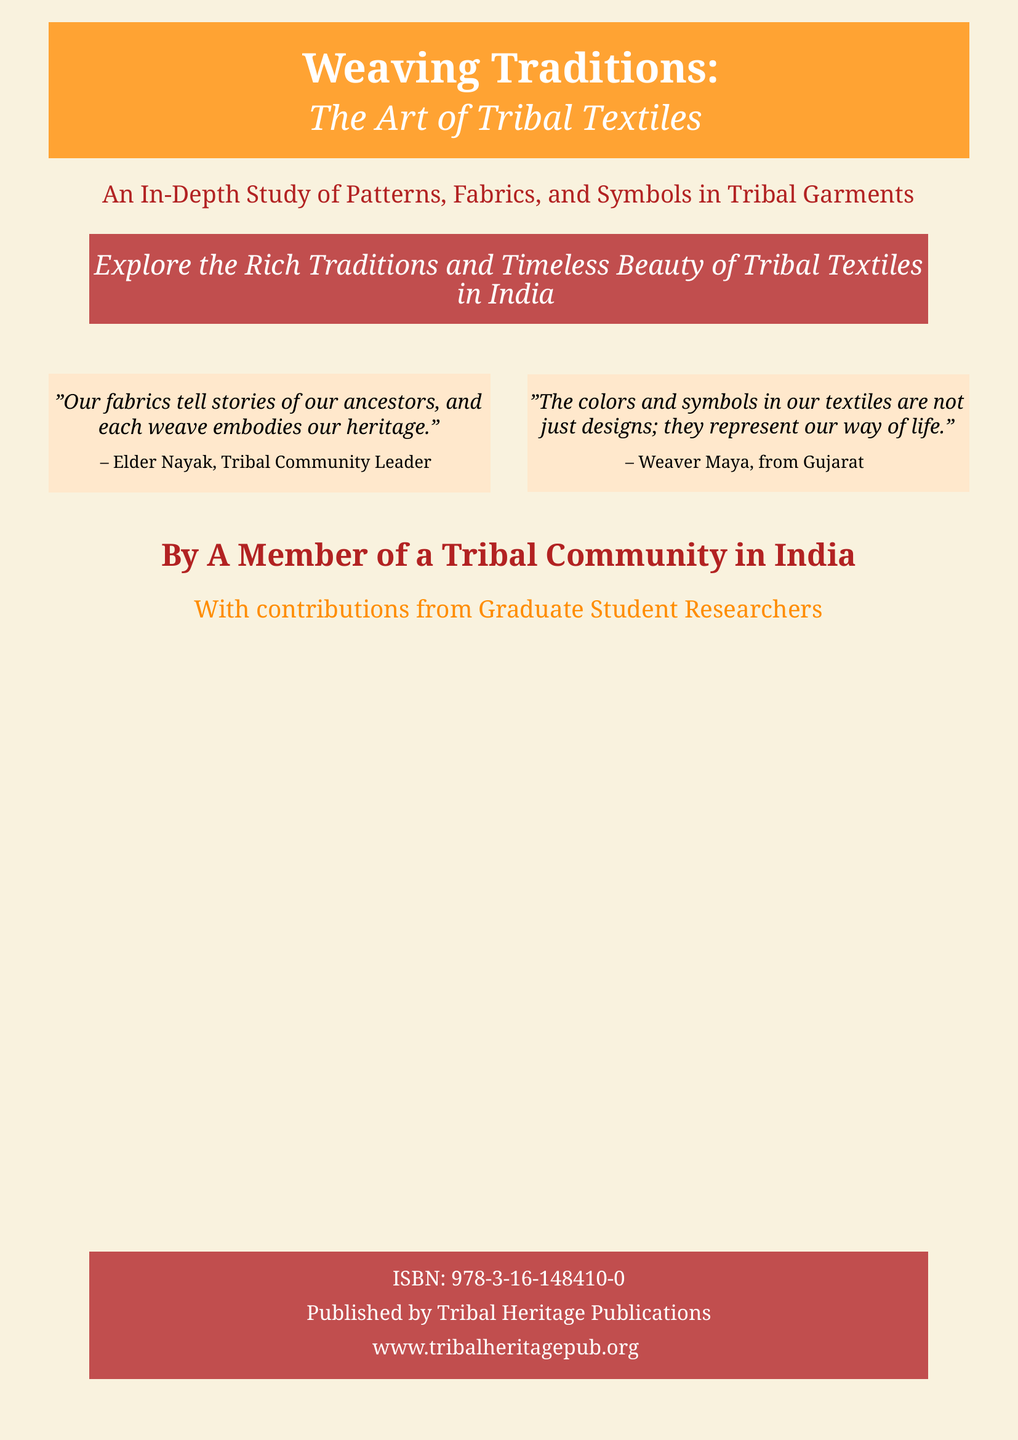What is the title of the book? The title is prominently displayed on the cover and it is "Weaving Traditions: The Art of Tribal Textiles".
Answer: Weaving Traditions: The Art of Tribal Textiles Who is the author of the book? The book is authored by a member of a tribal community in India, as stated on the cover.
Answer: A Member of a Tribal Community in India What does the book focus on? The subtitle indicates that the book is an in-depth study of patterns, fabrics, and symbols in tribal garments.
Answer: Patterns, fabrics, and symbols in tribal garments What is the ISBN of the book? The ISBN is a unique identifier for the book as mentioned at the bottom of the cover.
Answer: 978-3-16-148410-0 Who published the book? The cover specifies that it was published by Tribal Heritage Publications.
Answer: Tribal Heritage Publications What do the colors and symbols in the textiles represent, according to Weaver Maya? The statement reflects a deeper meaning associated with the colors and symbols, as mentioned in the quote.
Answer: Our way of life What is the publication website? The website for more information about the publication is stated at the bottom of the cover.
Answer: www.tribalheritagepub.org What color is used for the book’s background? The background color is mentioned in the document design details, creating a specific aesthetic.
Answer: Tribal gold What is the main message conveyed by Elder Nayak? The quote provided highlights the historical significance of the fabrics in tribal culture.
Answer: Our fabrics tell stories of our ancestors 